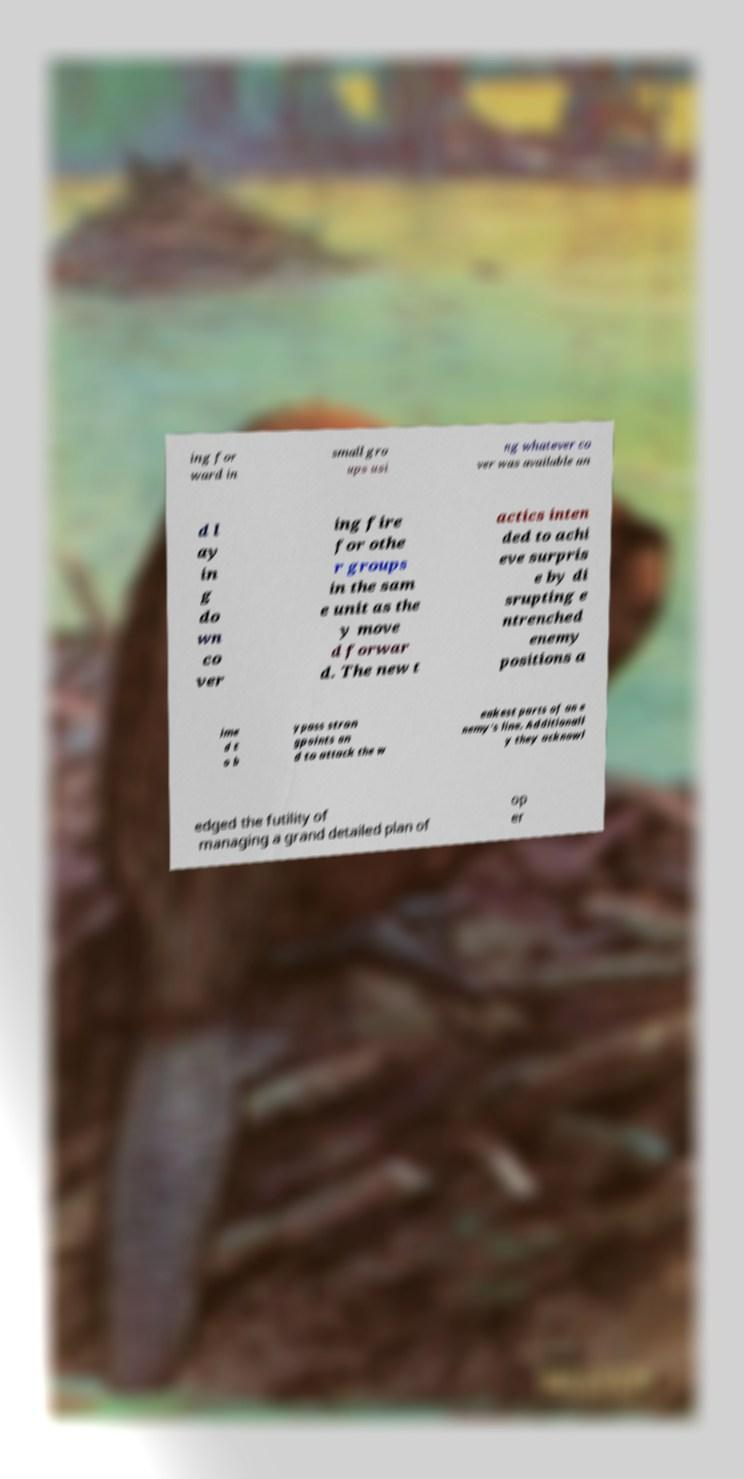There's text embedded in this image that I need extracted. Can you transcribe it verbatim? ing for ward in small gro ups usi ng whatever co ver was available an d l ay in g do wn co ver ing fire for othe r groups in the sam e unit as the y move d forwar d. The new t actics inten ded to achi eve surpris e by di srupting e ntrenched enemy positions a ime d t o b ypass stron gpoints an d to attack the w eakest parts of an e nemy's line. Additionall y they acknowl edged the futility of managing a grand detailed plan of op er 